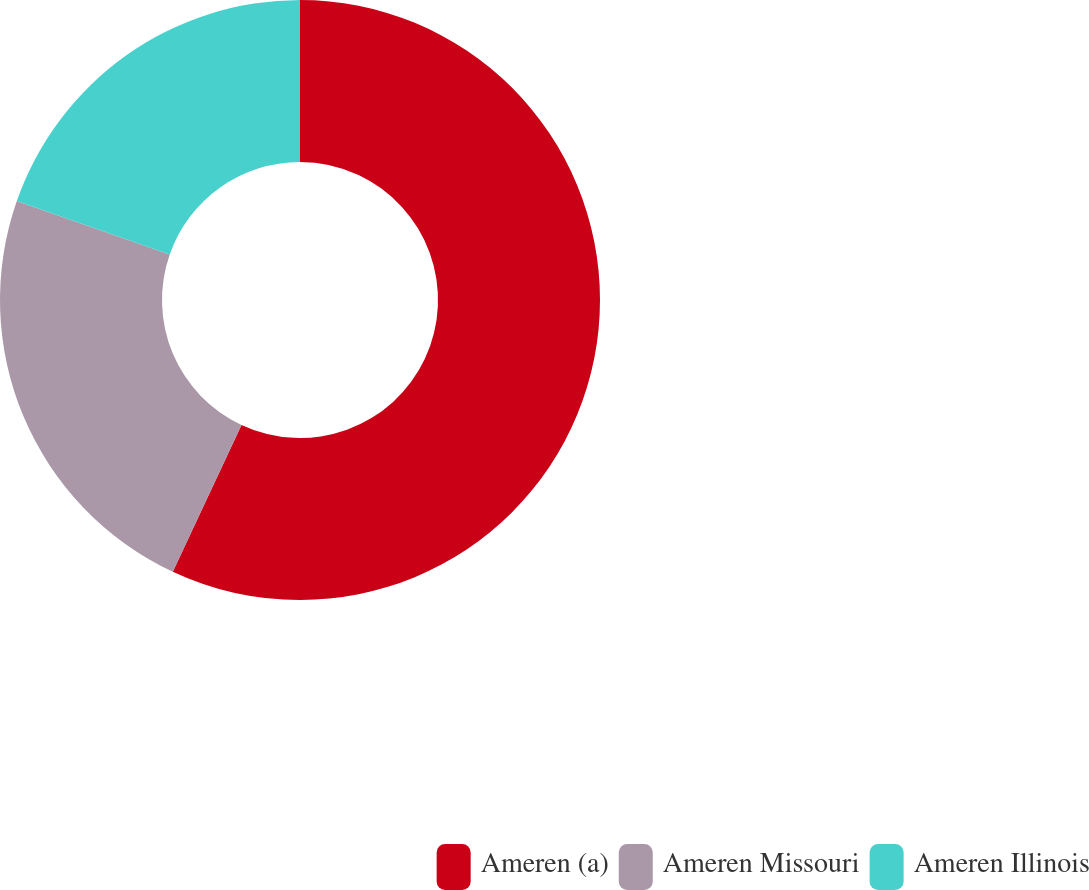Convert chart. <chart><loc_0><loc_0><loc_500><loc_500><pie_chart><fcel>Ameren (a)<fcel>Ameren Missouri<fcel>Ameren Illinois<nl><fcel>56.97%<fcel>23.38%<fcel>19.65%<nl></chart> 